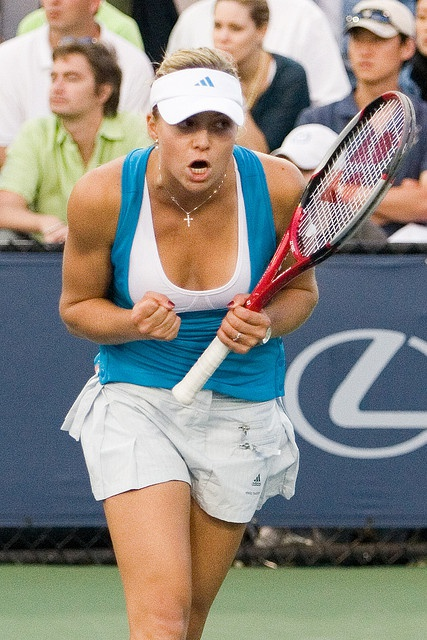Describe the objects in this image and their specific colors. I can see people in gray, lightgray, tan, brown, and teal tones, people in gray, beige, and tan tones, tennis racket in gray, lightgray, darkgray, and black tones, people in gray, lightgray, beige, and tan tones, and people in gray, salmon, and lightgray tones in this image. 